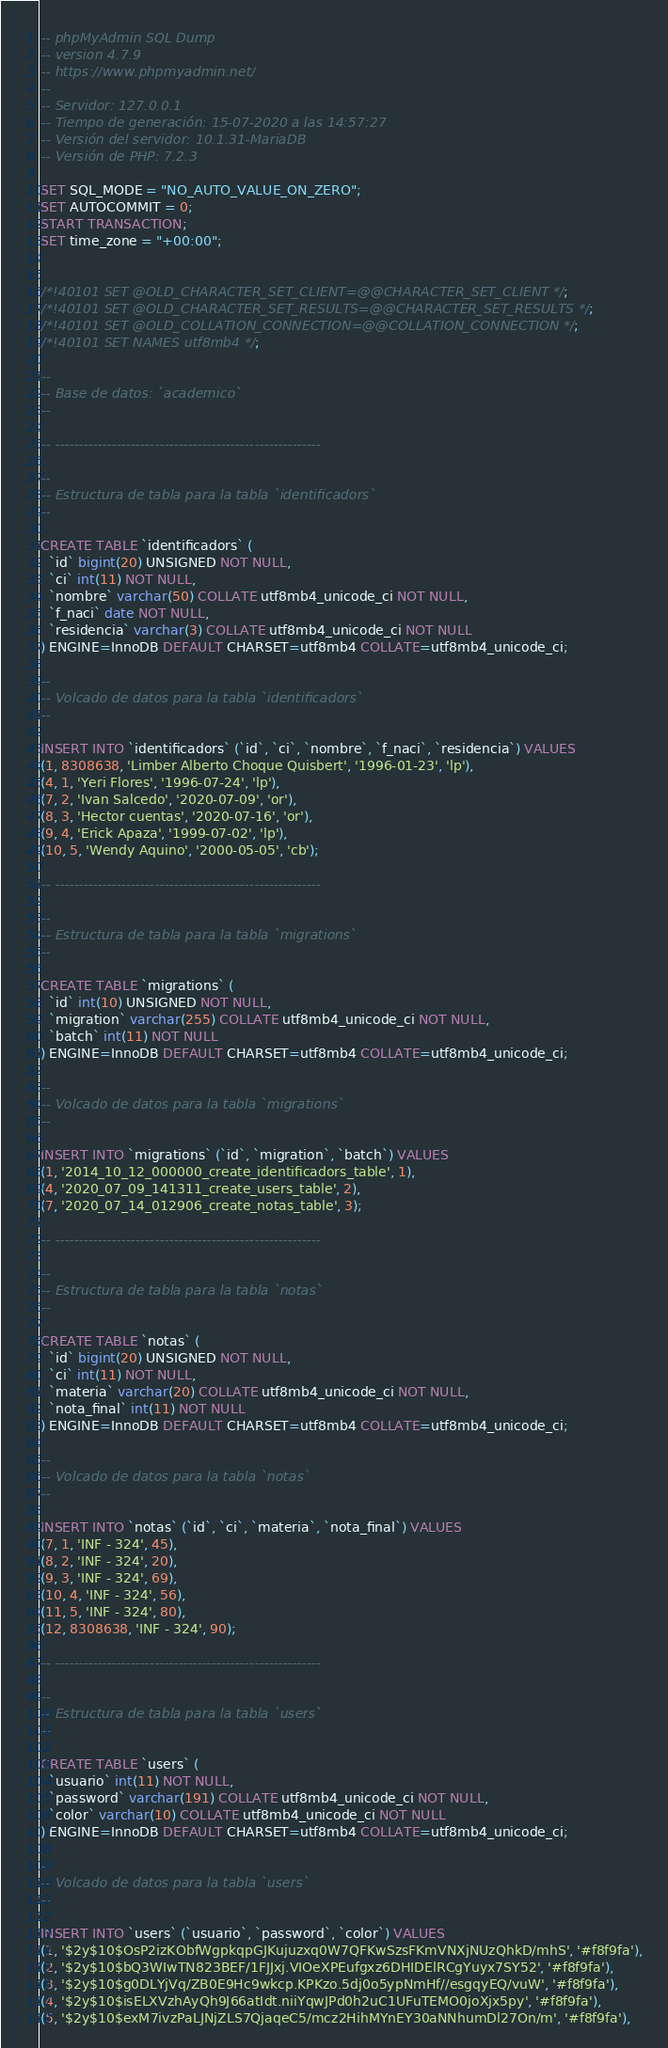Convert code to text. <code><loc_0><loc_0><loc_500><loc_500><_SQL_>-- phpMyAdmin SQL Dump
-- version 4.7.9
-- https://www.phpmyadmin.net/
--
-- Servidor: 127.0.0.1
-- Tiempo de generación: 15-07-2020 a las 14:57:27
-- Versión del servidor: 10.1.31-MariaDB
-- Versión de PHP: 7.2.3

SET SQL_MODE = "NO_AUTO_VALUE_ON_ZERO";
SET AUTOCOMMIT = 0;
START TRANSACTION;
SET time_zone = "+00:00";


/*!40101 SET @OLD_CHARACTER_SET_CLIENT=@@CHARACTER_SET_CLIENT */;
/*!40101 SET @OLD_CHARACTER_SET_RESULTS=@@CHARACTER_SET_RESULTS */;
/*!40101 SET @OLD_COLLATION_CONNECTION=@@COLLATION_CONNECTION */;
/*!40101 SET NAMES utf8mb4 */;

--
-- Base de datos: `academico`
--

-- --------------------------------------------------------

--
-- Estructura de tabla para la tabla `identificadors`
--

CREATE TABLE `identificadors` (
  `id` bigint(20) UNSIGNED NOT NULL,
  `ci` int(11) NOT NULL,
  `nombre` varchar(50) COLLATE utf8mb4_unicode_ci NOT NULL,
  `f_naci` date NOT NULL,
  `residencia` varchar(3) COLLATE utf8mb4_unicode_ci NOT NULL
) ENGINE=InnoDB DEFAULT CHARSET=utf8mb4 COLLATE=utf8mb4_unicode_ci;

--
-- Volcado de datos para la tabla `identificadors`
--

INSERT INTO `identificadors` (`id`, `ci`, `nombre`, `f_naci`, `residencia`) VALUES
(1, 8308638, 'Limber Alberto Choque Quisbert', '1996-01-23', 'lp'),
(4, 1, 'Yeri Flores', '1996-07-24', 'lp'),
(7, 2, 'Ivan Salcedo', '2020-07-09', 'or'),
(8, 3, 'Hector cuentas', '2020-07-16', 'or'),
(9, 4, 'Erick Apaza', '1999-07-02', 'lp'),
(10, 5, 'Wendy Aquino', '2000-05-05', 'cb');

-- --------------------------------------------------------

--
-- Estructura de tabla para la tabla `migrations`
--

CREATE TABLE `migrations` (
  `id` int(10) UNSIGNED NOT NULL,
  `migration` varchar(255) COLLATE utf8mb4_unicode_ci NOT NULL,
  `batch` int(11) NOT NULL
) ENGINE=InnoDB DEFAULT CHARSET=utf8mb4 COLLATE=utf8mb4_unicode_ci;

--
-- Volcado de datos para la tabla `migrations`
--

INSERT INTO `migrations` (`id`, `migration`, `batch`) VALUES
(1, '2014_10_12_000000_create_identificadors_table', 1),
(4, '2020_07_09_141311_create_users_table', 2),
(7, '2020_07_14_012906_create_notas_table', 3);

-- --------------------------------------------------------

--
-- Estructura de tabla para la tabla `notas`
--

CREATE TABLE `notas` (
  `id` bigint(20) UNSIGNED NOT NULL,
  `ci` int(11) NOT NULL,
  `materia` varchar(20) COLLATE utf8mb4_unicode_ci NOT NULL,
  `nota_final` int(11) NOT NULL
) ENGINE=InnoDB DEFAULT CHARSET=utf8mb4 COLLATE=utf8mb4_unicode_ci;

--
-- Volcado de datos para la tabla `notas`
--

INSERT INTO `notas` (`id`, `ci`, `materia`, `nota_final`) VALUES
(7, 1, 'INF - 324', 45),
(8, 2, 'INF - 324', 20),
(9, 3, 'INF - 324', 69),
(10, 4, 'INF - 324', 56),
(11, 5, 'INF - 324', 80),
(12, 8308638, 'INF - 324', 90);

-- --------------------------------------------------------

--
-- Estructura de tabla para la tabla `users`
--

CREATE TABLE `users` (
  `usuario` int(11) NOT NULL,
  `password` varchar(191) COLLATE utf8mb4_unicode_ci NOT NULL,
  `color` varchar(10) COLLATE utf8mb4_unicode_ci NOT NULL
) ENGINE=InnoDB DEFAULT CHARSET=utf8mb4 COLLATE=utf8mb4_unicode_ci;

--
-- Volcado de datos para la tabla `users`
--

INSERT INTO `users` (`usuario`, `password`, `color`) VALUES
(1, '$2y$10$OsP2izKObfWgpkqpGJKujuzxq0W7QFKwSzsFKmVNXjNUzQhkD/mhS', '#f8f9fa'),
(2, '$2y$10$bQ3WIwTN823BEF/1FJJxj.VIOeXPEufgxz6DHIDElRCgYuyx7SY52', '#f8f9fa'),
(3, '$2y$10$g0DLYjVq/ZB0E9Hc9wkcp.KPKzo.5dj0o5ypNmHf//esgqyEQ/vuW', '#f8f9fa'),
(4, '$2y$10$isELXVzhAyQh9J66atIdt.niiYqwJPd0h2uC1UFuTEMO0joXjx5py', '#f8f9fa'),
(5, '$2y$10$exM7ivzPaLJNjZLS7QjaqeC5/mcz2HihMYnEY30aNNhumDl27On/m', '#f8f9fa'),</code> 